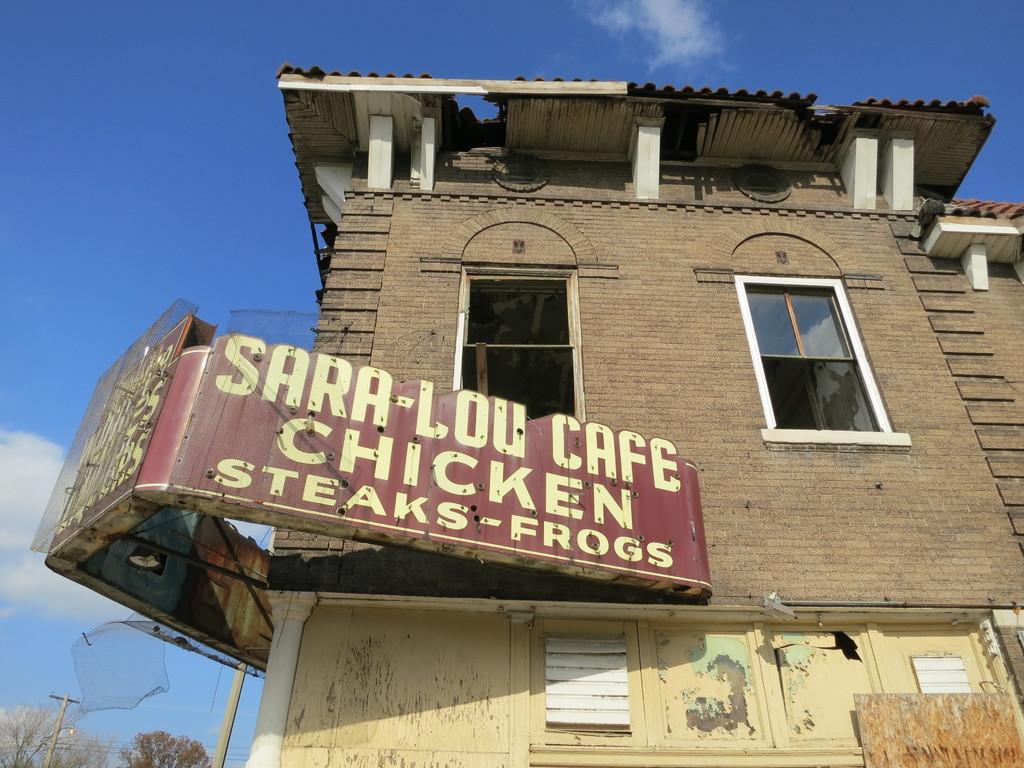Describe this image in one or two sentences. In the foreground of this image, there are board to a building. In the background, there is sky, cloud, a pole, cables and trees. 